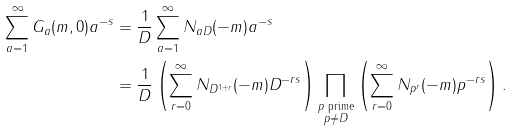Convert formula to latex. <formula><loc_0><loc_0><loc_500><loc_500>\sum _ { a = 1 } ^ { \infty } G _ { a } ( m , 0 ) a ^ { - s } & = \frac { 1 } { D } \sum _ { a = 1 } ^ { \infty } N _ { a D } ( - m ) a ^ { - s } \\ & = \frac { 1 } { D } \left ( \sum _ { r = 0 } ^ { \infty } N _ { D ^ { 1 + r } } ( - m ) D ^ { - r s } \right ) \prod _ { \substack { \text {$p$ prime} \\ p \neq D } } \left ( \sum _ { r = 0 } ^ { \infty } N _ { p ^ { r } } ( - m ) p ^ { - r s } \right ) .</formula> 